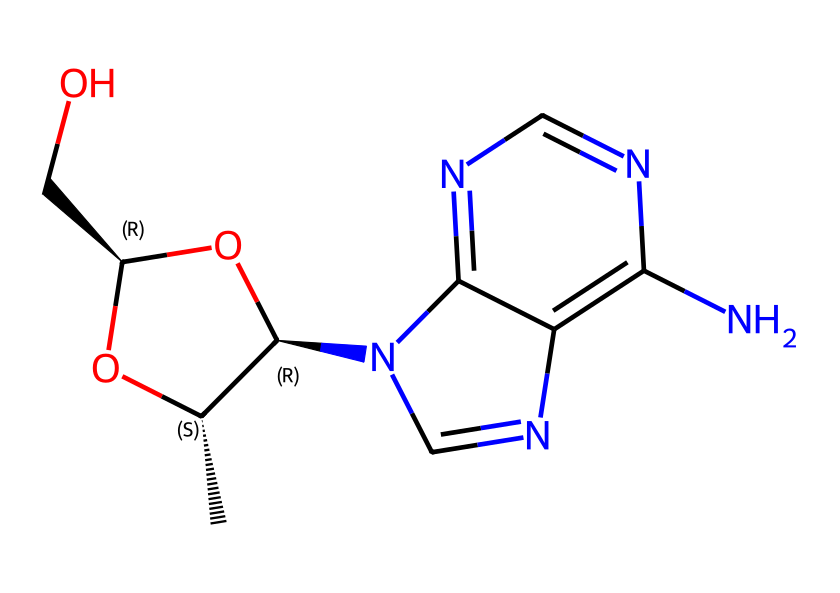What is the molecular formula of the compound? To determine the molecular formula, we count the number of each type of atom present in the SMILES representation. By parsing the structure, we find it contains: 10 carbon (C) atoms, 14 hydrogen (H) atoms, 4 nitrogen (N) atoms, and 5 oxygen (O) atoms. Therefore, the molecular formula is C10H14N4O5.
Answer: C10H14N4O5 How many chiral centers are present in this molecule? A chiral center is typically a carbon atom bonded to four distinct substituents. By examining the structure, we identify two carbon atoms that have unique substituents attached. Therefore, there are 2 chiral centers present.
Answer: 2 What type of chemical is this compound classified as? Given its structure containing nitrogen and the arrangement of the functional groups, this compound is classified as an antibiotic due to its potential effect on bacteria.
Answer: antibiotic How many rings are present in this molecule? To find the number of rings, we analyze the structure and see that there are two fused ring systems present. Therefore, the total number of rings in this chemical is 2.
Answer: 2 What is the significance of the amino groups in this structure? The amino groups (NH2) in the structure are important for biological activity, enhancing the compound's ability to interact with bacterial targets and represent a major functional component of many antibiotics, contributing to their effectiveness.
Answer: interact with bacteria 